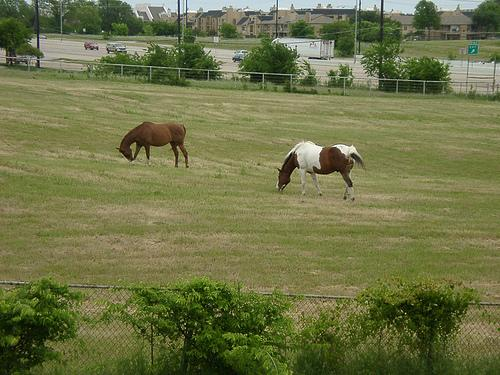Mention a few prominent elements in the image using short phrases. Grassy field, two horses grazing, chain link fence, bushes, highway traffic, suburban area. Describe the combination of colors and textures present in the image. The image displays a mixture of green and brown grass, bushes, and trees, along with vibrant colors from the suburban buildings and moving vehicles on the highway. Point out the features related to the fence and its surroundings. The field is enclosed by a metal chain link fence which has green bushes growing along it, with accompanying plants, a tree, and a small green shrub. Draw attention to notable elements involving vehicular traffic in the image. The image showcases a busy highway with passenger vehicles, including a white semi-truck, a heavy-duty truck, and a beige pickup truck, as well as a green exit sign. Please provide a brief overview of the scene in the image. The image shows two horses, one brown and one brown and white, grazing in a fenced field, with nearby highway traffic and a suburban background. Describe the landscape and setting of the image. A grassy field enclosed by a chain link fence houses two grazing horses, with green and brown bushes along the fence, a line of houses, and a nearby highway bustling with vehicles. Identify the types of buildings seen in the background of the image. The image features a suburban backdrop with a brown apartment complex and buildings having dark-colored roofs, situated behind the fenced grassy field. What type of environment and activity is depicted in the image? The image depicts a semi-urban environment where horses are grazing peacefully in a fenced field, close to a busy highway and a suburban community. In one sentence, summarize the primary setting of the image. The image captures a grassy fenced area with horses grazing, surrounded by a bustling suburban scene and highway traffic. Elaborate on the horses in the image and their actions. In the grassy field, a brown horse is bending over to graze while the brown and white horse is standing nearby, also eating grass. 